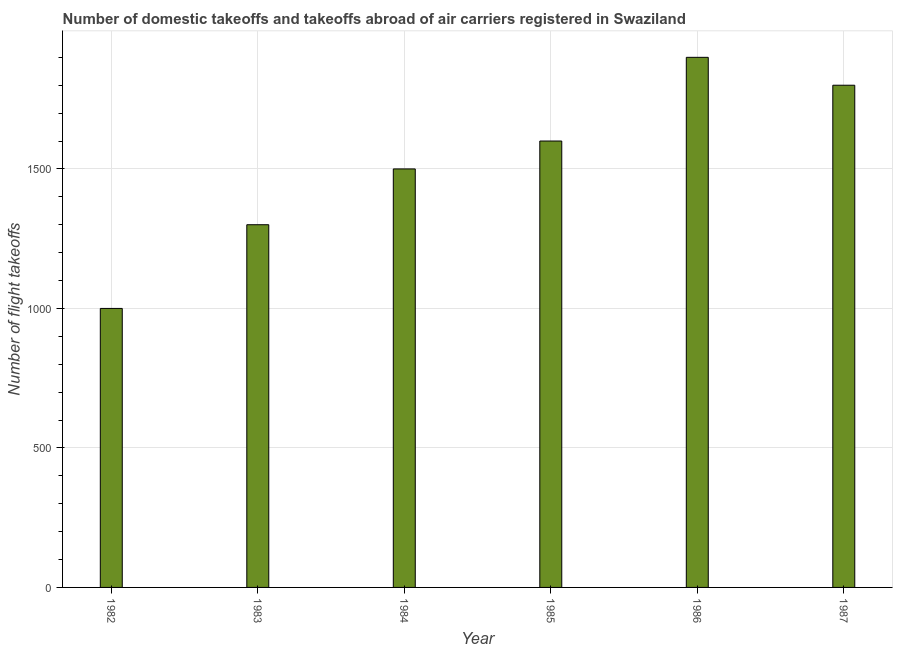What is the title of the graph?
Your response must be concise. Number of domestic takeoffs and takeoffs abroad of air carriers registered in Swaziland. What is the label or title of the X-axis?
Give a very brief answer. Year. What is the label or title of the Y-axis?
Your response must be concise. Number of flight takeoffs. What is the number of flight takeoffs in 1983?
Make the answer very short. 1300. Across all years, what is the maximum number of flight takeoffs?
Keep it short and to the point. 1900. Across all years, what is the minimum number of flight takeoffs?
Your answer should be very brief. 1000. What is the sum of the number of flight takeoffs?
Keep it short and to the point. 9100. What is the difference between the number of flight takeoffs in 1985 and 1986?
Offer a terse response. -300. What is the average number of flight takeoffs per year?
Provide a short and direct response. 1516. What is the median number of flight takeoffs?
Give a very brief answer. 1550. Do a majority of the years between 1986 and 1985 (inclusive) have number of flight takeoffs greater than 300 ?
Ensure brevity in your answer.  No. What is the ratio of the number of flight takeoffs in 1982 to that in 1985?
Give a very brief answer. 0.62. Is the difference between the number of flight takeoffs in 1983 and 1984 greater than the difference between any two years?
Give a very brief answer. No. What is the difference between the highest and the second highest number of flight takeoffs?
Ensure brevity in your answer.  100. Is the sum of the number of flight takeoffs in 1982 and 1987 greater than the maximum number of flight takeoffs across all years?
Make the answer very short. Yes. What is the difference between the highest and the lowest number of flight takeoffs?
Offer a terse response. 900. In how many years, is the number of flight takeoffs greater than the average number of flight takeoffs taken over all years?
Keep it short and to the point. 3. How many bars are there?
Offer a terse response. 6. Are all the bars in the graph horizontal?
Keep it short and to the point. No. How many years are there in the graph?
Your answer should be compact. 6. What is the difference between two consecutive major ticks on the Y-axis?
Provide a short and direct response. 500. Are the values on the major ticks of Y-axis written in scientific E-notation?
Make the answer very short. No. What is the Number of flight takeoffs of 1982?
Make the answer very short. 1000. What is the Number of flight takeoffs of 1983?
Give a very brief answer. 1300. What is the Number of flight takeoffs of 1984?
Offer a very short reply. 1500. What is the Number of flight takeoffs of 1985?
Offer a terse response. 1600. What is the Number of flight takeoffs in 1986?
Provide a succinct answer. 1900. What is the Number of flight takeoffs of 1987?
Provide a short and direct response. 1800. What is the difference between the Number of flight takeoffs in 1982 and 1983?
Your answer should be compact. -300. What is the difference between the Number of flight takeoffs in 1982 and 1984?
Offer a terse response. -500. What is the difference between the Number of flight takeoffs in 1982 and 1985?
Offer a terse response. -600. What is the difference between the Number of flight takeoffs in 1982 and 1986?
Keep it short and to the point. -900. What is the difference between the Number of flight takeoffs in 1982 and 1987?
Keep it short and to the point. -800. What is the difference between the Number of flight takeoffs in 1983 and 1984?
Your answer should be compact. -200. What is the difference between the Number of flight takeoffs in 1983 and 1985?
Provide a succinct answer. -300. What is the difference between the Number of flight takeoffs in 1983 and 1986?
Make the answer very short. -600. What is the difference between the Number of flight takeoffs in 1983 and 1987?
Offer a terse response. -500. What is the difference between the Number of flight takeoffs in 1984 and 1985?
Your answer should be compact. -100. What is the difference between the Number of flight takeoffs in 1984 and 1986?
Give a very brief answer. -400. What is the difference between the Number of flight takeoffs in 1984 and 1987?
Provide a short and direct response. -300. What is the difference between the Number of flight takeoffs in 1985 and 1986?
Ensure brevity in your answer.  -300. What is the difference between the Number of flight takeoffs in 1985 and 1987?
Make the answer very short. -200. What is the ratio of the Number of flight takeoffs in 1982 to that in 1983?
Provide a succinct answer. 0.77. What is the ratio of the Number of flight takeoffs in 1982 to that in 1984?
Your response must be concise. 0.67. What is the ratio of the Number of flight takeoffs in 1982 to that in 1986?
Provide a short and direct response. 0.53. What is the ratio of the Number of flight takeoffs in 1982 to that in 1987?
Offer a terse response. 0.56. What is the ratio of the Number of flight takeoffs in 1983 to that in 1984?
Ensure brevity in your answer.  0.87. What is the ratio of the Number of flight takeoffs in 1983 to that in 1985?
Ensure brevity in your answer.  0.81. What is the ratio of the Number of flight takeoffs in 1983 to that in 1986?
Offer a very short reply. 0.68. What is the ratio of the Number of flight takeoffs in 1983 to that in 1987?
Provide a succinct answer. 0.72. What is the ratio of the Number of flight takeoffs in 1984 to that in 1985?
Keep it short and to the point. 0.94. What is the ratio of the Number of flight takeoffs in 1984 to that in 1986?
Give a very brief answer. 0.79. What is the ratio of the Number of flight takeoffs in 1984 to that in 1987?
Give a very brief answer. 0.83. What is the ratio of the Number of flight takeoffs in 1985 to that in 1986?
Your answer should be compact. 0.84. What is the ratio of the Number of flight takeoffs in 1985 to that in 1987?
Your answer should be compact. 0.89. What is the ratio of the Number of flight takeoffs in 1986 to that in 1987?
Your answer should be very brief. 1.06. 